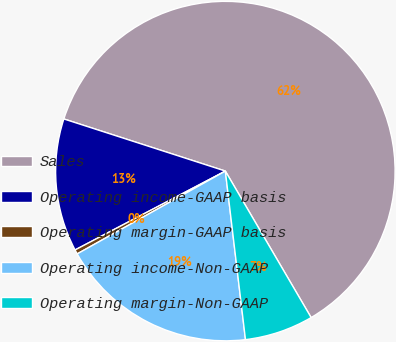<chart> <loc_0><loc_0><loc_500><loc_500><pie_chart><fcel>Sales<fcel>Operating income-GAAP basis<fcel>Operating margin-GAAP basis<fcel>Operating income-Non-GAAP<fcel>Operating margin-Non-GAAP<nl><fcel>61.6%<fcel>12.66%<fcel>0.42%<fcel>18.78%<fcel>6.54%<nl></chart> 